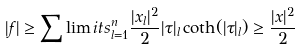Convert formula to latex. <formula><loc_0><loc_0><loc_500><loc_500>| f | \geq \sum \lim i t s _ { l = 1 } ^ { n } \frac { | x _ { l } | ^ { 2 } } { 2 } | \tau | _ { l } \coth ( | \tau | _ { l } ) \geq \frac { | x | ^ { 2 } } { 2 }</formula> 